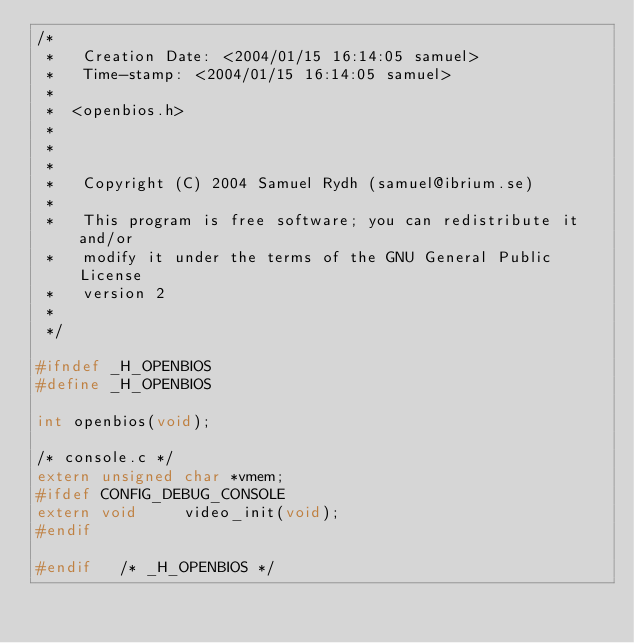Convert code to text. <code><loc_0><loc_0><loc_500><loc_500><_C_>/*
 *   Creation Date: <2004/01/15 16:14:05 samuel>
 *   Time-stamp: <2004/01/15 16:14:05 samuel>
 *
 *	<openbios.h>
 *
 *
 *
 *   Copyright (C) 2004 Samuel Rydh (samuel@ibrium.se)
 *
 *   This program is free software; you can redistribute it and/or
 *   modify it under the terms of the GNU General Public License
 *   version 2
 *
 */

#ifndef _H_OPENBIOS
#define _H_OPENBIOS

int openbios(void);

/* console.c */
extern unsigned char *vmem;
#ifdef CONFIG_DEBUG_CONSOLE
extern void     video_init(void);
#endif

#endif   /* _H_OPENBIOS */
</code> 